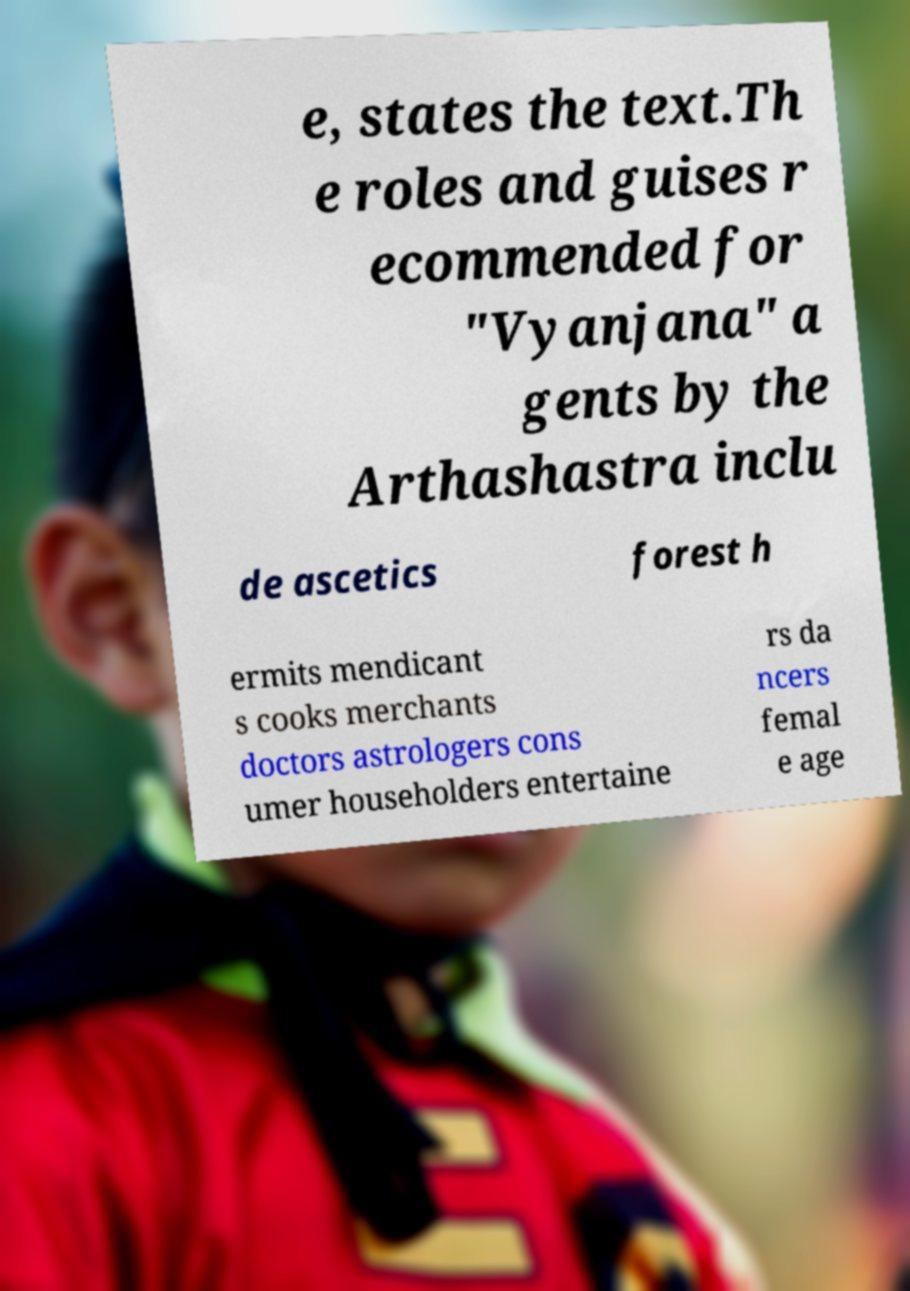Please read and relay the text visible in this image. What does it say? e, states the text.Th e roles and guises r ecommended for "Vyanjana" a gents by the Arthashastra inclu de ascetics forest h ermits mendicant s cooks merchants doctors astrologers cons umer householders entertaine rs da ncers femal e age 